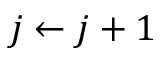Convert formula to latex. <formula><loc_0><loc_0><loc_500><loc_500>j \leftarrow j + 1</formula> 